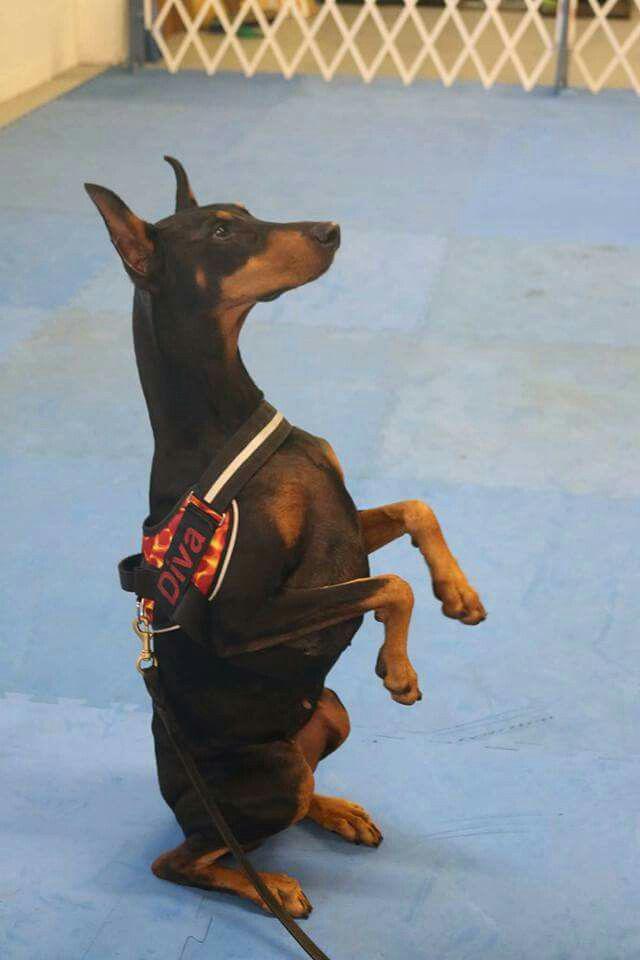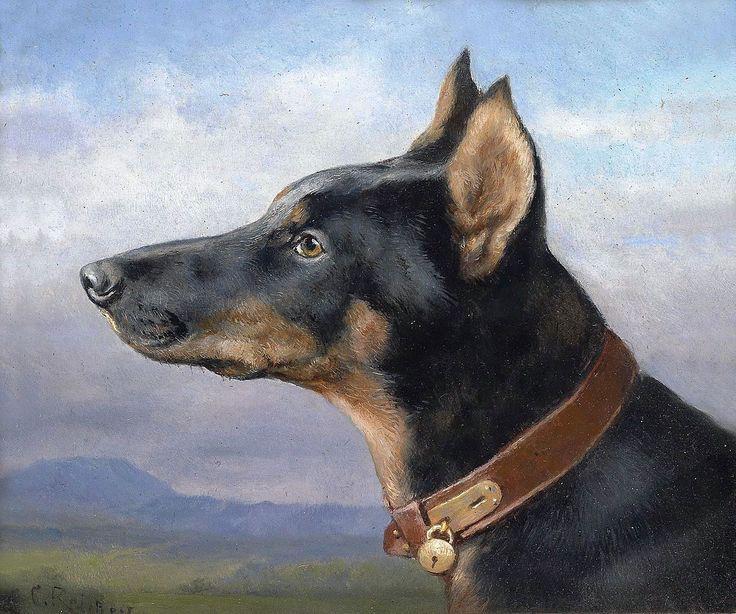The first image is the image on the left, the second image is the image on the right. Examine the images to the left and right. Is the description "In one of the images, the dogs are wearing things on their paws." accurate? Answer yes or no. No. The first image is the image on the left, the second image is the image on the right. Evaluate the accuracy of this statement regarding the images: "In one of the images, a doberman is holding an object in its mouth.". Is it true? Answer yes or no. No. 